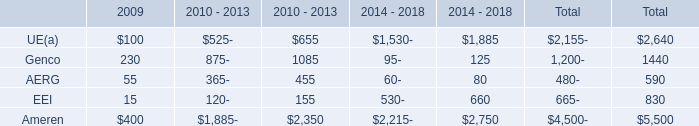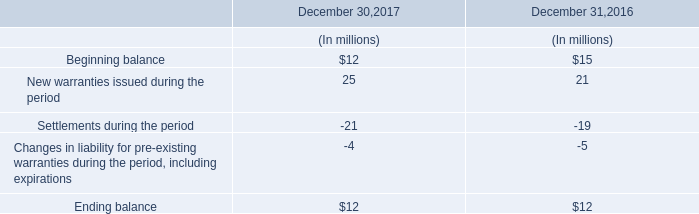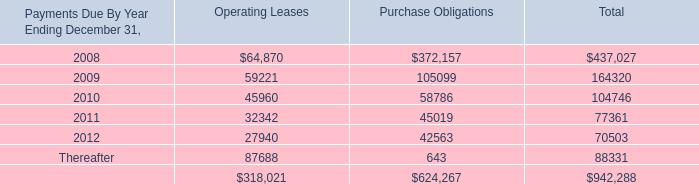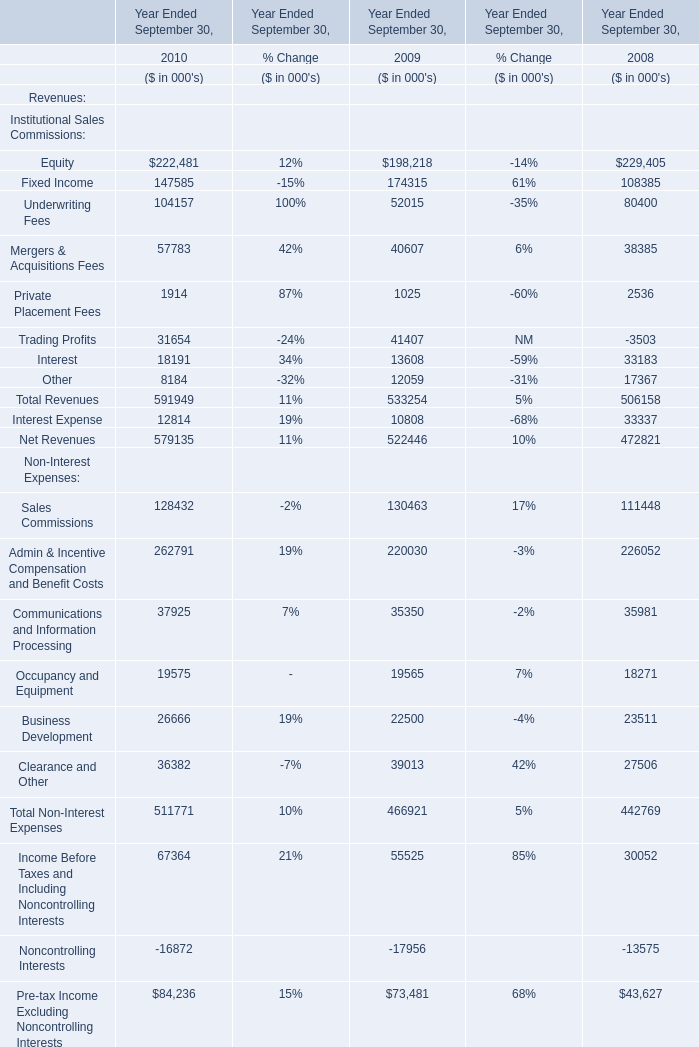As As the chart 3 shows,in the year Ended September 30 where Total Revenues is the lowest, what's the Net Revenues? (in thousand) 
Answer: 472821. 